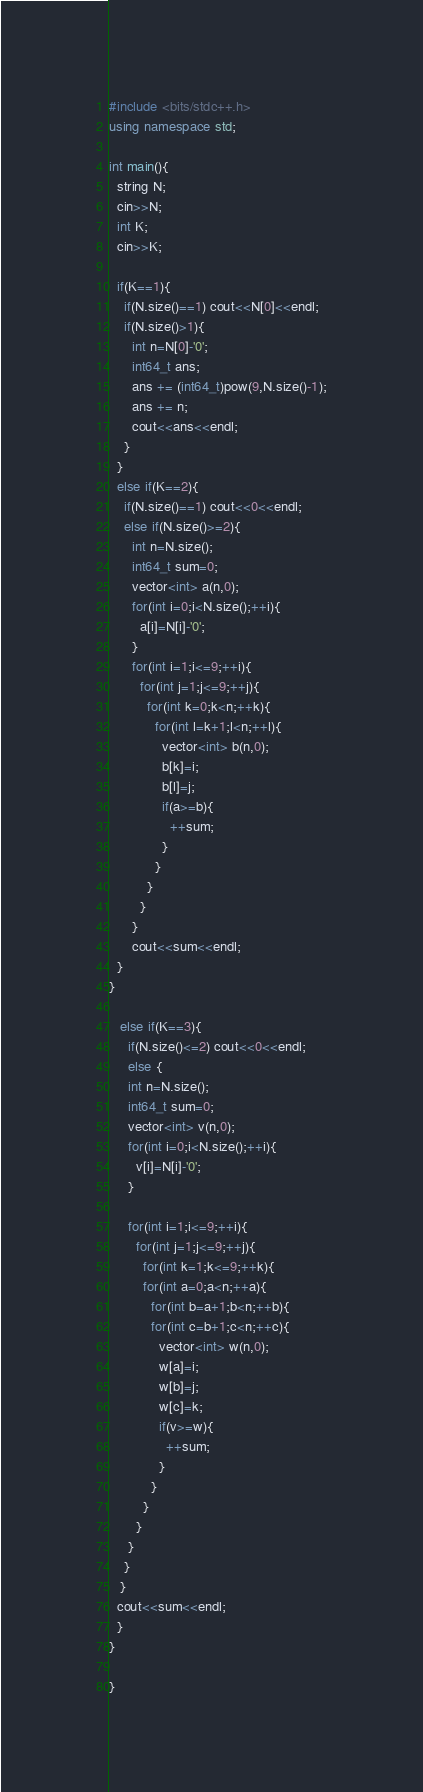Convert code to text. <code><loc_0><loc_0><loc_500><loc_500><_C++_>#include <bits/stdc++.h>
using namespace std;

int main(){
  string N;
  cin>>N;
  int K;
  cin>>K;

  if(K==1){
    if(N.size()==1) cout<<N[0]<<endl;
    if(N.size()>1){
      int n=N[0]-'0';
      int64_t ans;
      ans += (int64_t)pow(9,N.size()-1);
      ans += n;
      cout<<ans<<endl;
    }
  }
  else if(K==2){
    if(N.size()==1) cout<<0<<endl;
    else if(N.size()>=2){
      int n=N.size();
      int64_t sum=0;
      vector<int> a(n,0);
      for(int i=0;i<N.size();++i){
        a[i]=N[i]-'0';
      }
      for(int i=1;i<=9;++i){
        for(int j=1;j<=9;++j){
          for(int k=0;k<n;++k){
            for(int l=k+1;l<n;++l){
              vector<int> b(n,0);
              b[k]=i;
              b[l]=j;
              if(a>=b){
                ++sum;
              }
            }
          }
        }
      }
      cout<<sum<<endl;
  }
}

   else if(K==3){
     if(N.size()<=2) cout<<0<<endl;
     else {
     int n=N.size();
     int64_t sum=0;
     vector<int> v(n,0);
     for(int i=0;i<N.size();++i){
       v[i]=N[i]-'0';
     }
     
     for(int i=1;i<=9;++i){
       for(int j=1;j<=9;++j){
         for(int k=1;k<=9;++k){
         for(int a=0;a<n;++a){
           for(int b=a+1;b<n;++b){
           for(int c=b+1;c<n;++c){
             vector<int> w(n,0);
             w[a]=i;
             w[b]=j;
             w[c]=k;
             if(v>=w){
               ++sum;
             }
           }
         }
       }
     }
    }
   }
  cout<<sum<<endl;
  }
}

}</code> 